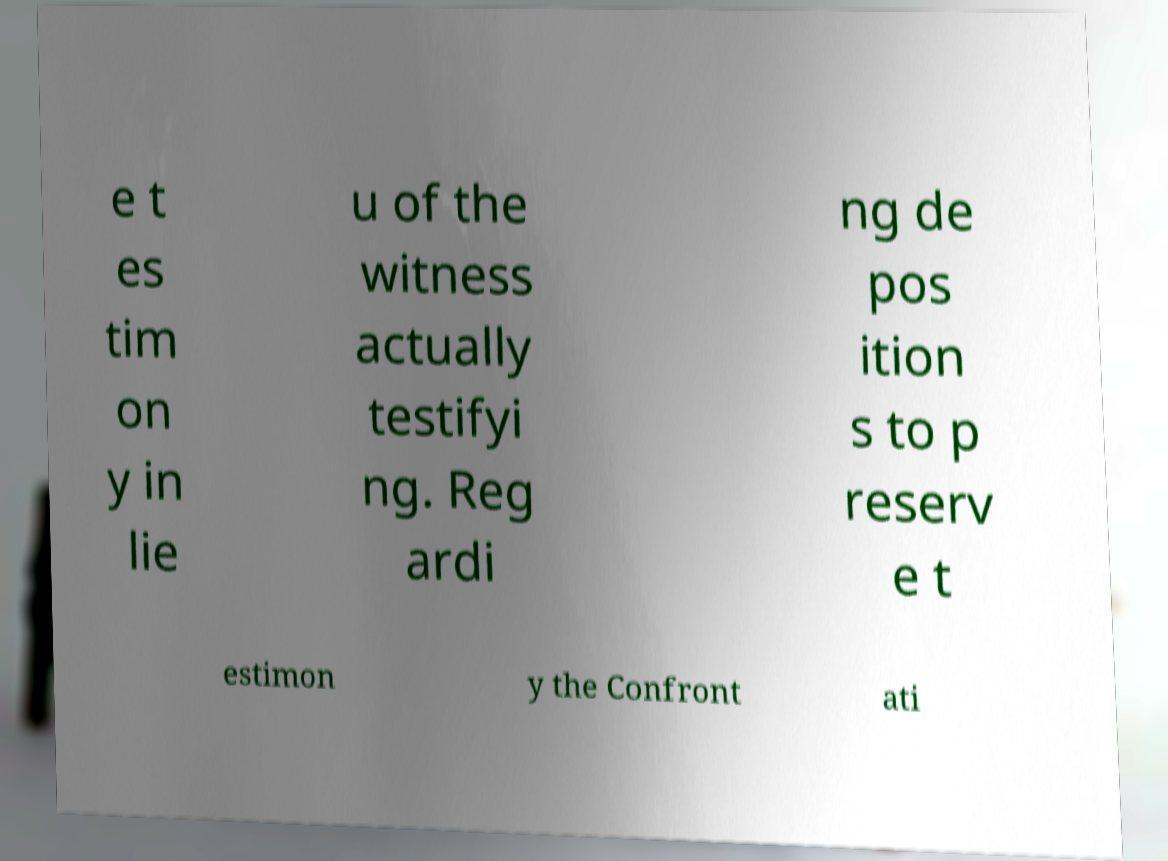For documentation purposes, I need the text within this image transcribed. Could you provide that? e t es tim on y in lie u of the witness actually testifyi ng. Reg ardi ng de pos ition s to p reserv e t estimon y the Confront ati 